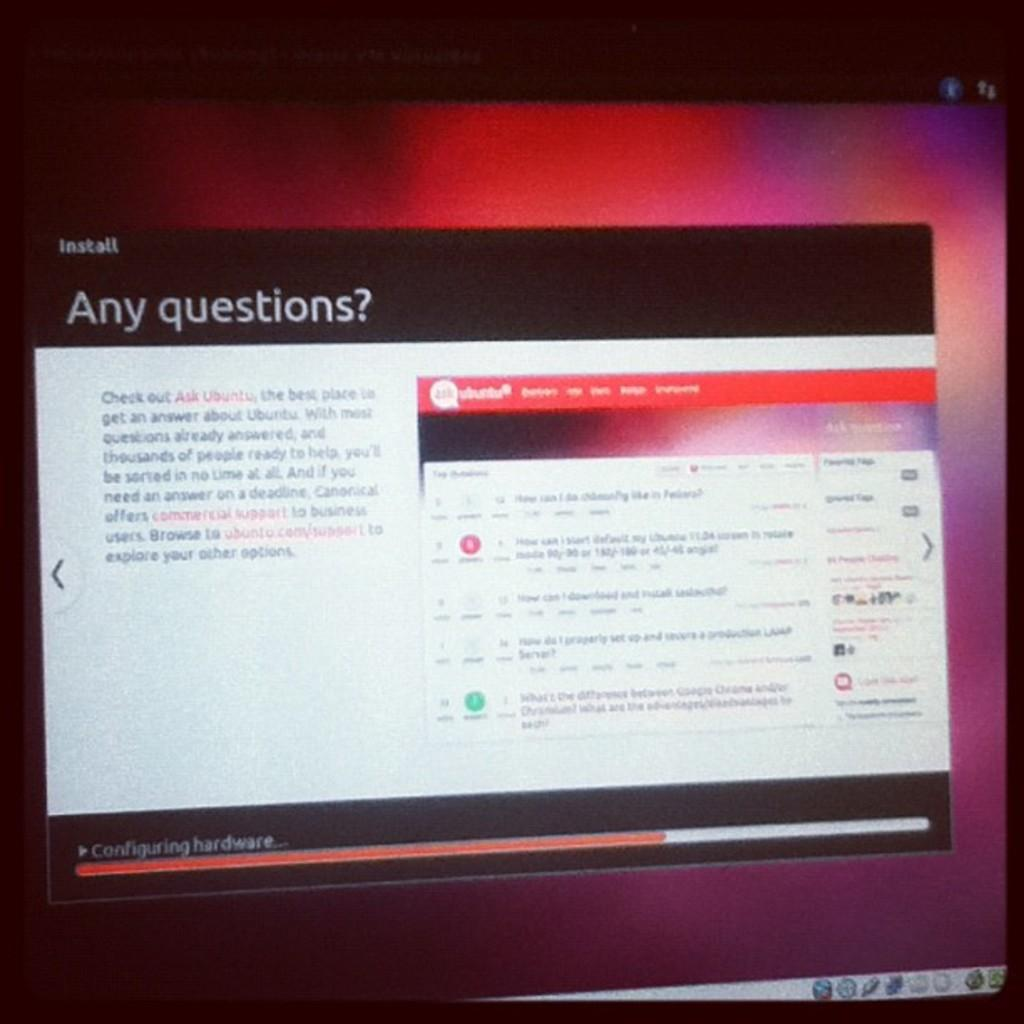<image>
Summarize the visual content of the image. A software installation screen showing hardware is currently being configured. 